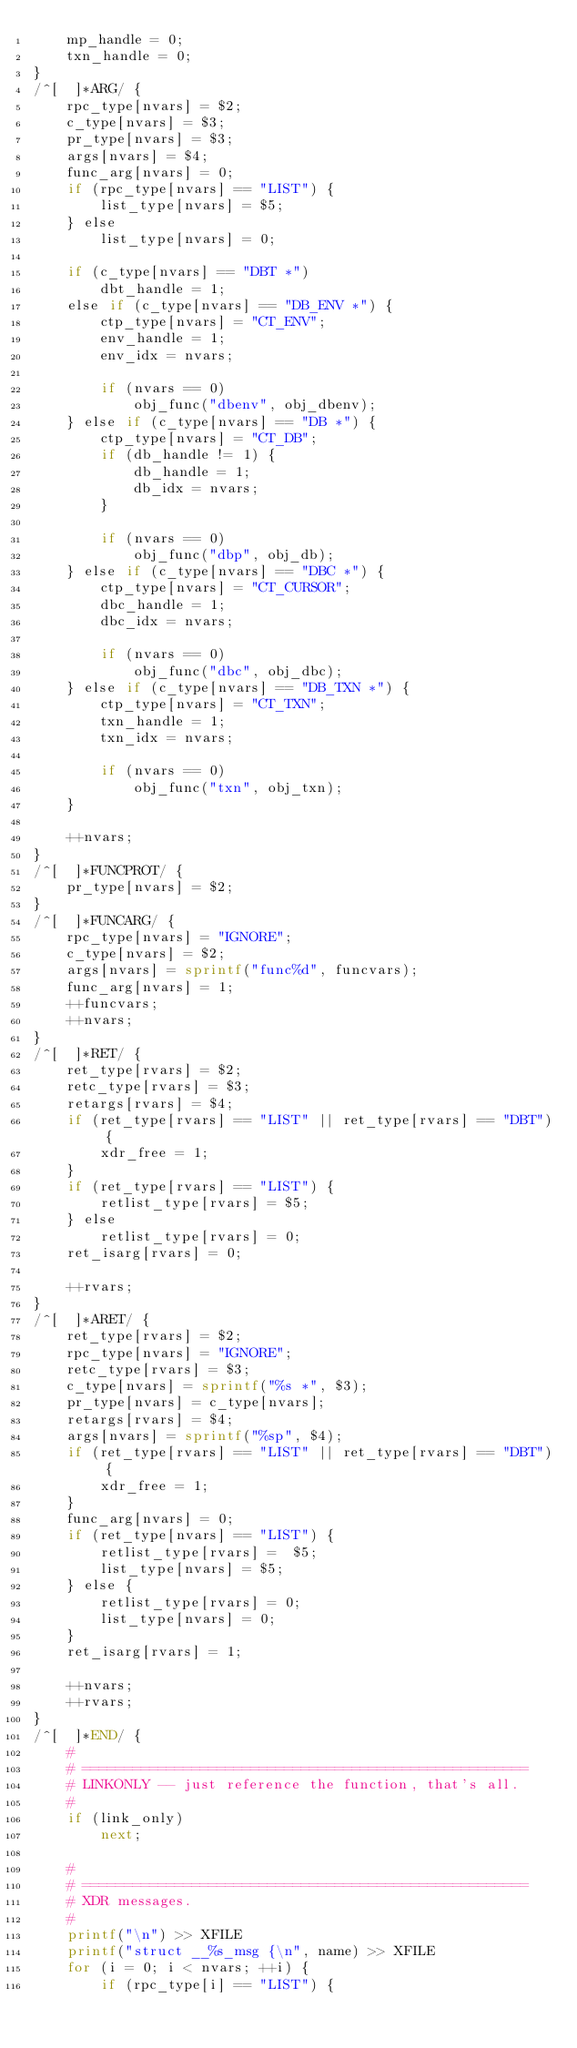<code> <loc_0><loc_0><loc_500><loc_500><_Awk_>	mp_handle = 0;
	txn_handle = 0;
}
/^[	 ]*ARG/ {
	rpc_type[nvars] = $2;
	c_type[nvars] = $3;
	pr_type[nvars] = $3;
	args[nvars] = $4;
	func_arg[nvars] = 0;
	if (rpc_type[nvars] == "LIST") {
		list_type[nvars] = $5;
	} else
		list_type[nvars] = 0;

	if (c_type[nvars] == "DBT *")
		dbt_handle = 1;
	else if (c_type[nvars] == "DB_ENV *") {
		ctp_type[nvars] = "CT_ENV";
		env_handle = 1;
		env_idx = nvars;

		if (nvars == 0)
			obj_func("dbenv", obj_dbenv);
	} else if (c_type[nvars] == "DB *") {
		ctp_type[nvars] = "CT_DB";
		if (db_handle != 1) {
			db_handle = 1;
			db_idx = nvars;
		}

		if (nvars == 0)
			obj_func("dbp", obj_db);
	} else if (c_type[nvars] == "DBC *") {
		ctp_type[nvars] = "CT_CURSOR";
		dbc_handle = 1;
		dbc_idx = nvars;

		if (nvars == 0)
			obj_func("dbc", obj_dbc);
	} else if (c_type[nvars] == "DB_TXN *") {
		ctp_type[nvars] = "CT_TXN";
		txn_handle = 1;
		txn_idx = nvars;

		if (nvars == 0)
			obj_func("txn", obj_txn);
	}

	++nvars;
}
/^[	 ]*FUNCPROT/ {
	pr_type[nvars] = $2;
}
/^[	 ]*FUNCARG/ {
	rpc_type[nvars] = "IGNORE";
	c_type[nvars] = $2;
	args[nvars] = sprintf("func%d", funcvars);
	func_arg[nvars] = 1;
	++funcvars;
	++nvars;
}
/^[	 ]*RET/ {
	ret_type[rvars] = $2;
	retc_type[rvars] = $3;
	retargs[rvars] = $4;
	if (ret_type[rvars] == "LIST" || ret_type[rvars] == "DBT") {
		xdr_free = 1;
	}
	if (ret_type[rvars] == "LIST") {
		retlist_type[rvars] = $5;
	} else
		retlist_type[rvars] = 0;
	ret_isarg[rvars] = 0;

	++rvars;
}
/^[	 ]*ARET/ {
	ret_type[rvars] = $2;
	rpc_type[nvars] = "IGNORE";
	retc_type[rvars] = $3;
	c_type[nvars] = sprintf("%s *", $3);
	pr_type[nvars] = c_type[nvars];
	retargs[rvars] = $4;
	args[nvars] = sprintf("%sp", $4);
	if (ret_type[rvars] == "LIST" || ret_type[rvars] == "DBT") {
		xdr_free = 1;
	}
	func_arg[nvars] = 0;
	if (ret_type[nvars] == "LIST") {
		retlist_type[rvars] =  $5;
		list_type[nvars] = $5;
	} else {
		retlist_type[rvars] = 0;
		list_type[nvars] = 0;
	}
	ret_isarg[rvars] = 1;

	++nvars;
	++rvars;
}
/^[	 ]*END/ {
	#
	# =====================================================
	# LINKONLY -- just reference the function, that's all.
	#
	if (link_only)
		next;

	#
	# =====================================================
	# XDR messages.
	#
	printf("\n") >> XFILE
	printf("struct __%s_msg {\n", name) >> XFILE
	for (i = 0; i < nvars; ++i) {
		if (rpc_type[i] == "LIST") {</code> 